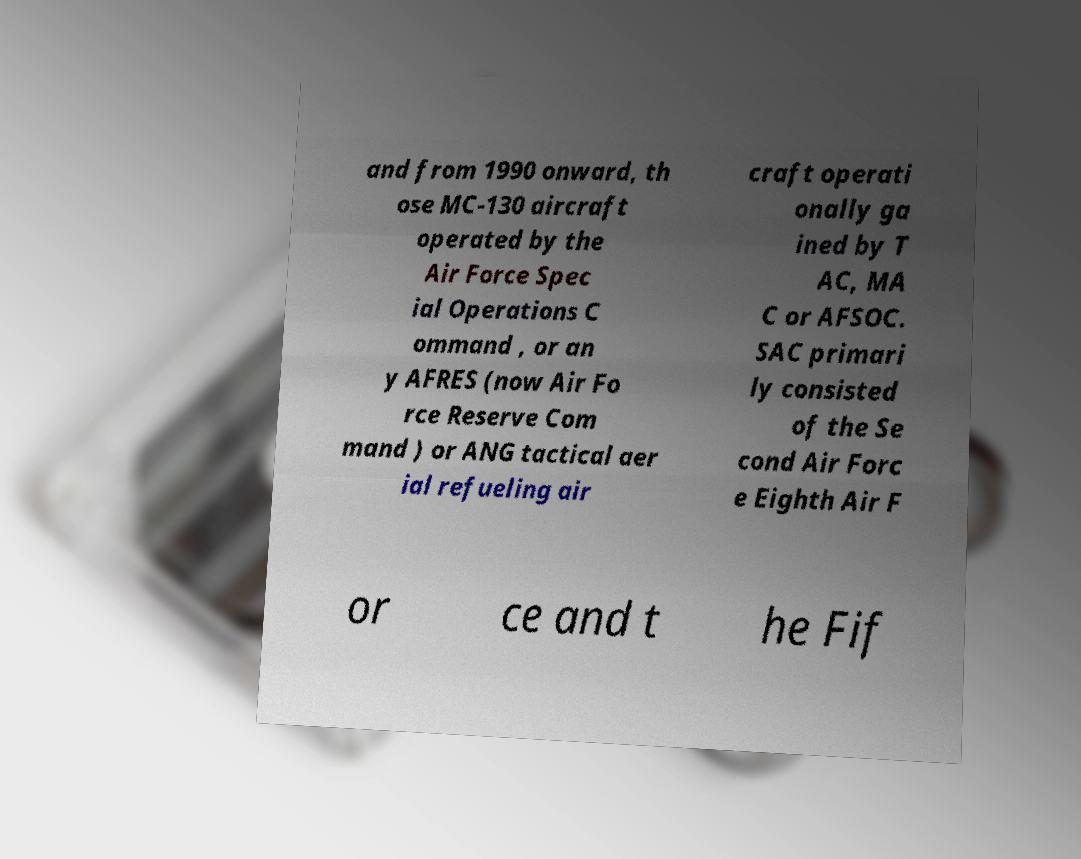Can you read and provide the text displayed in the image?This photo seems to have some interesting text. Can you extract and type it out for me? and from 1990 onward, th ose MC-130 aircraft operated by the Air Force Spec ial Operations C ommand , or an y AFRES (now Air Fo rce Reserve Com mand ) or ANG tactical aer ial refueling air craft operati onally ga ined by T AC, MA C or AFSOC. SAC primari ly consisted of the Se cond Air Forc e Eighth Air F or ce and t he Fif 